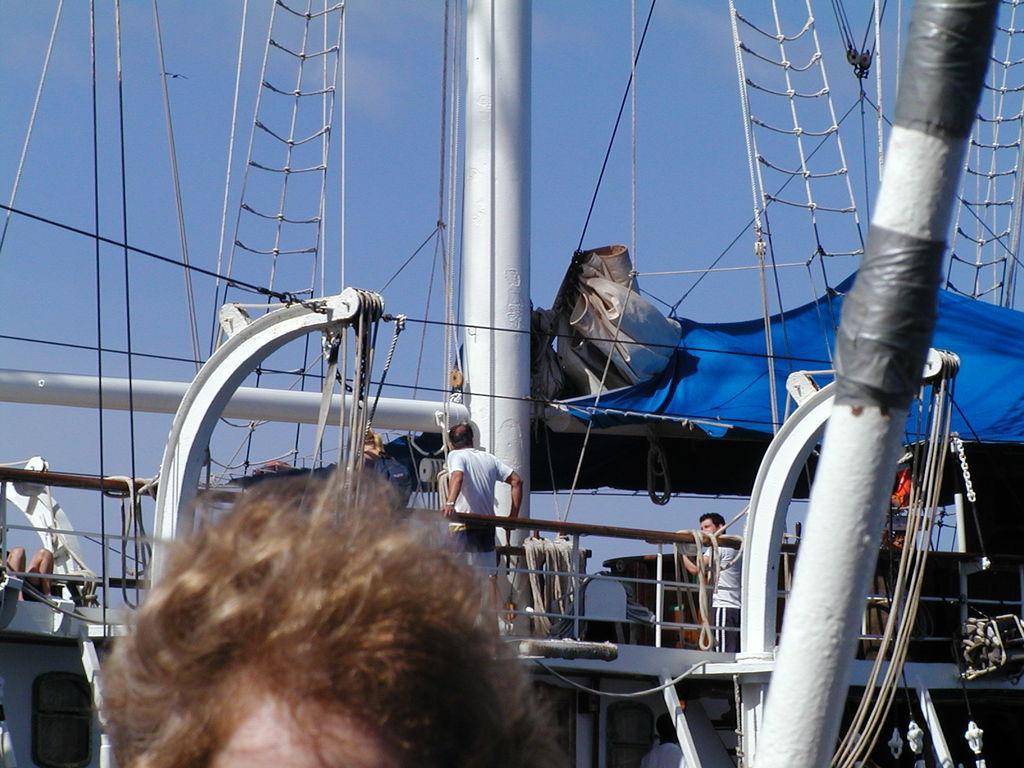How would you summarize this image in a sentence or two? In this image there is a person standing, in the background there is a ship, on that ship there are people standing and there is the sky. 